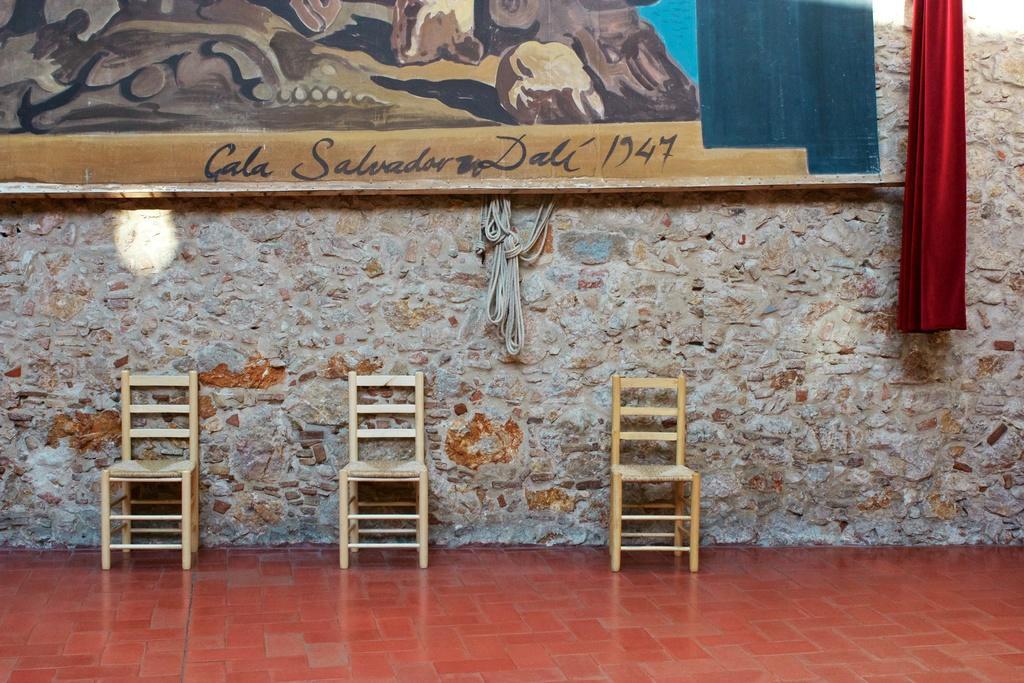<image>
Share a concise interpretation of the image provided. A large piece of art is signed by Salvador Dali and dated with the year 1974. 